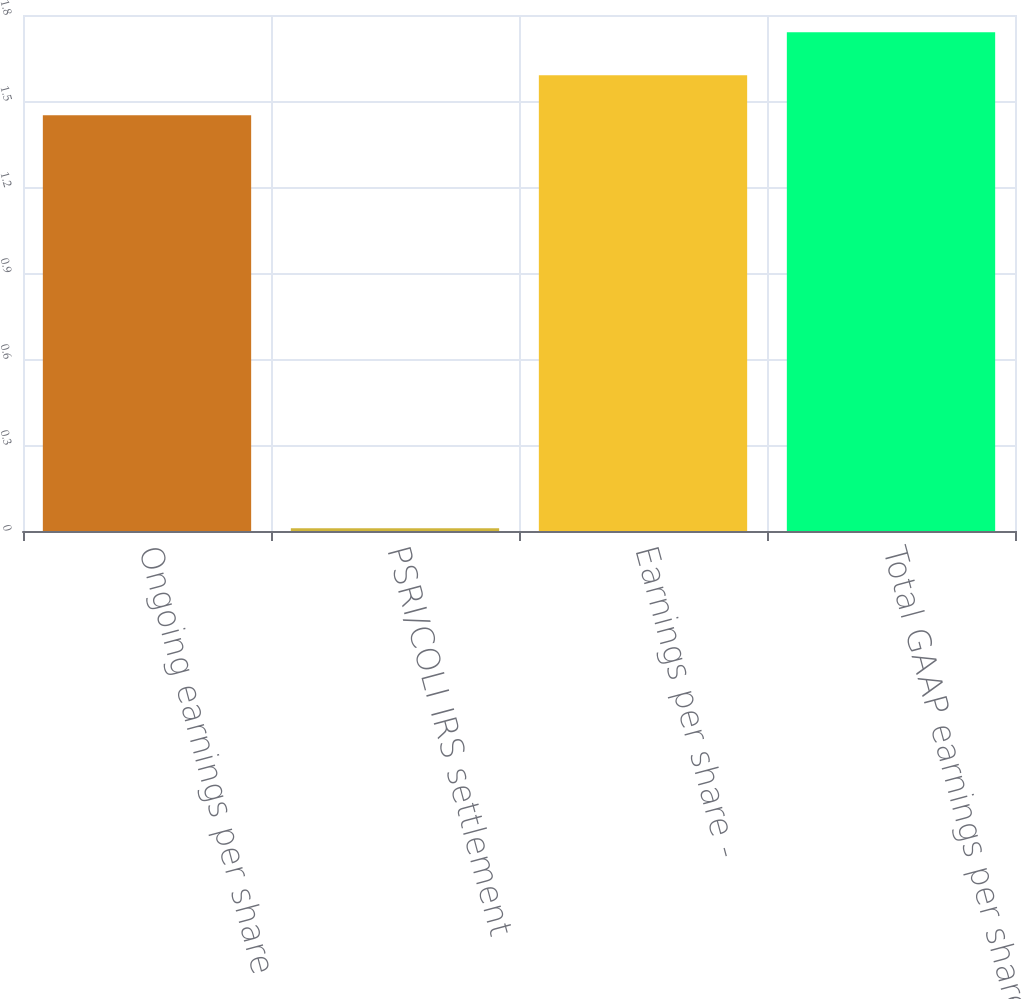Convert chart to OTSL. <chart><loc_0><loc_0><loc_500><loc_500><bar_chart><fcel>Ongoing earnings per share<fcel>PSRI/COLI IRS settlement<fcel>Earnings per share -<fcel>Total GAAP earnings per share<nl><fcel>1.45<fcel>0.01<fcel>1.59<fcel>1.74<nl></chart> 